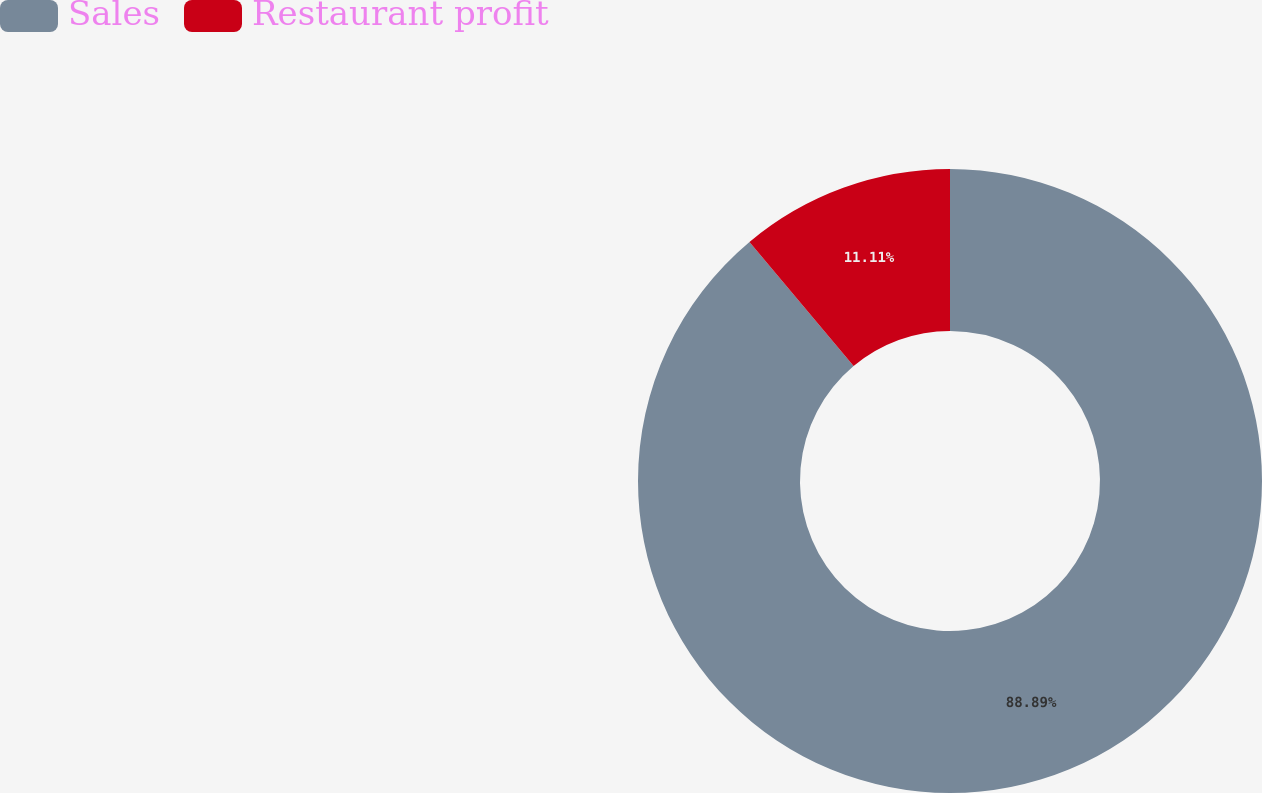<chart> <loc_0><loc_0><loc_500><loc_500><pie_chart><fcel>Sales<fcel>Restaurant profit<nl><fcel>88.89%<fcel>11.11%<nl></chart> 